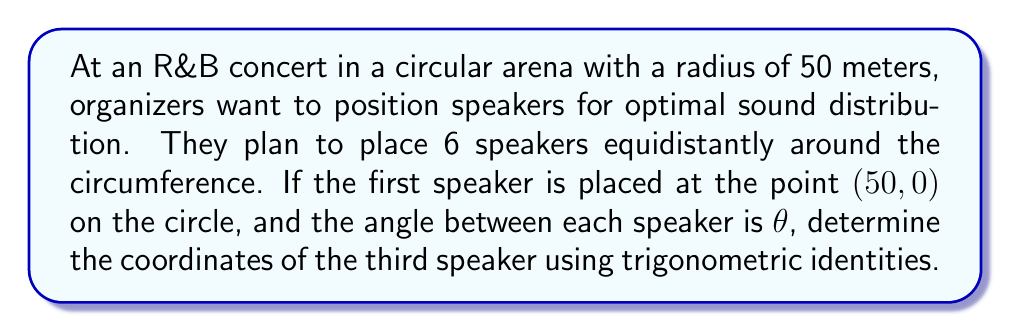Give your solution to this math problem. Let's approach this step-by-step:

1) First, we need to calculate the angle θ between each speaker:
   $$\theta = \frac{360^\circ}{6} = 60^\circ$$

2) The third speaker will be positioned at an angle of 2θ = 120° from the first speaker.

3) To find the coordinates, we can use the parametric equations of a circle:
   $$x = r \cos(\alpha)$$
   $$y = r \sin(\alpha)$$
   where r is the radius and α is the angle from the positive x-axis.

4) In this case, r = 50 and α = 120°. We need to calculate:
   $$x = 50 \cos(120^\circ)$$
   $$y = 50 \sin(120^\circ)$$

5) Using the trigonometric identities for 120°:
   $$\cos(120^\circ) = -\frac{1}{2}$$
   $$\sin(120^\circ) = \frac{\sqrt{3}}{2}$$

6) Substituting these values:
   $$x = 50 \cdot (-\frac{1}{2}) = -25$$
   $$y = 50 \cdot (\frac{\sqrt{3}}{2}) = 25\sqrt{3}$$

Therefore, the coordinates of the third speaker are (-25, 25√3).
Answer: (-25, 25√3) 